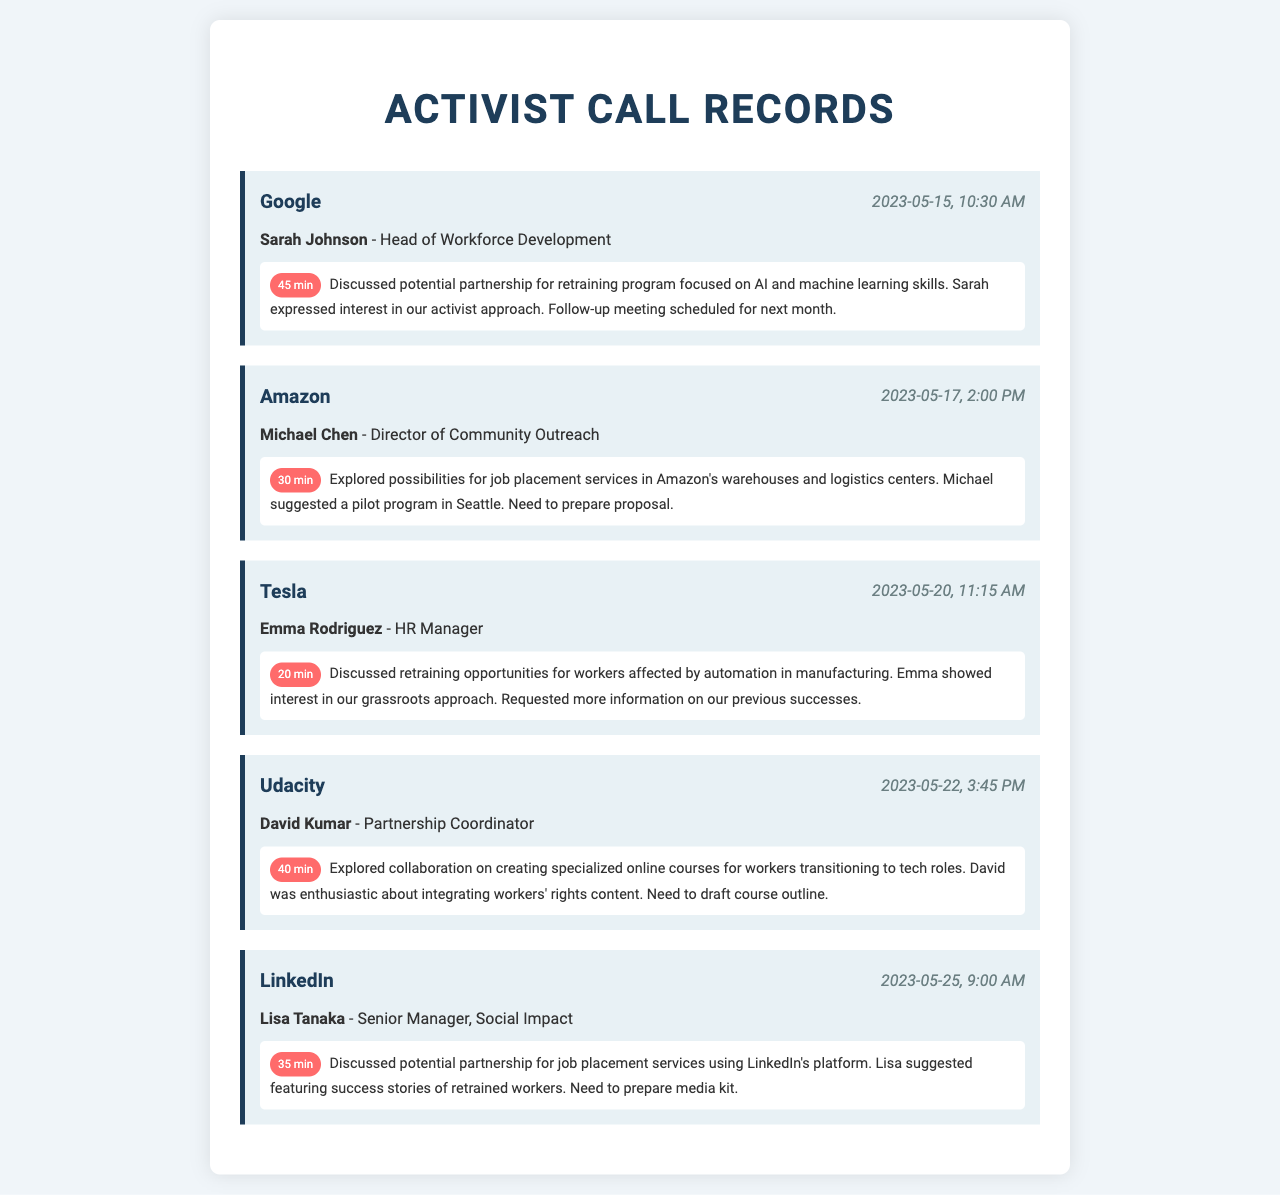What is the name of the Head of Workforce Development at Google? The name mentioned in the document is Sarah Johnson, who is the Head of Workforce Development at Google.
Answer: Sarah Johnson What date was the call with Amazon? The document indicates that the call with Amazon took place on May 17, 2023.
Answer: 2023-05-17 How long was the call with Tesla? The duration of the call with Tesla is specified as 20 minutes in the document.
Answer: 20 min What was discussed during the call with Udacity? The document states that the discussion revolved around creating specialized online courses for workers transitioning to tech roles.
Answer: Specialized online courses How many minutes did the call with LinkedIn last? The document notes that the call with LinkedIn lasted for 35 minutes.
Answer: 35 min Which company's HR Manager was contacted regarding automation? The document identifies Emma Rodriguez as the HR Manager from Tesla who was contacted about automation.
Answer: Tesla What suggestion did Lisa Tanaka make during the call with LinkedIn? Lisa suggested featuring success stories of retrained workers in the partnership for job placement services.
Answer: Success stories How much interest did Sarah express in the approach during the Google call? Sarah expressed interest in the activist approach during the call with Google.
Answer: Interest What is the primary focus of the partnership discussed with Tesla? The focus was on retraining opportunities for workers affected by automation in manufacturing.
Answer: Retraining opportunities 